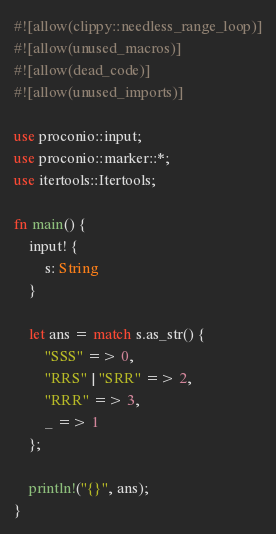Convert code to text. <code><loc_0><loc_0><loc_500><loc_500><_Rust_>#![allow(clippy::needless_range_loop)]
#![allow(unused_macros)]
#![allow(dead_code)]
#![allow(unused_imports)]

use proconio::input;
use proconio::marker::*;
use itertools::Itertools;

fn main() {
    input! {
        s: String
    }

    let ans = match s.as_str() {
        "SSS" => 0,
        "RRS" | "SRR" => 2,
        "RRR" => 3,
        _ => 1
    };

    println!("{}", ans);
}
</code> 